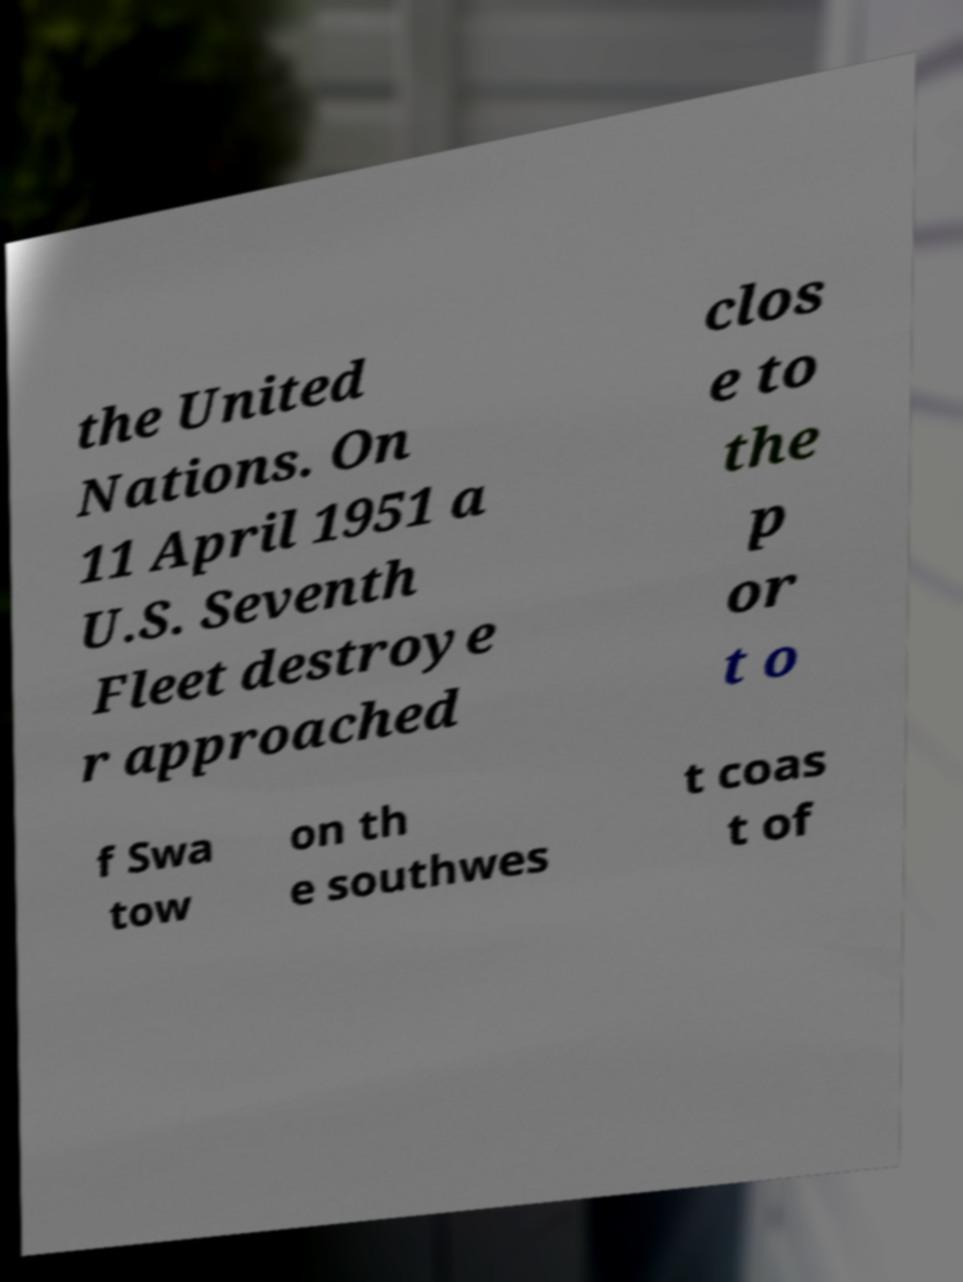What messages or text are displayed in this image? I need them in a readable, typed format. the United Nations. On 11 April 1951 a U.S. Seventh Fleet destroye r approached clos e to the p or t o f Swa tow on th e southwes t coas t of 